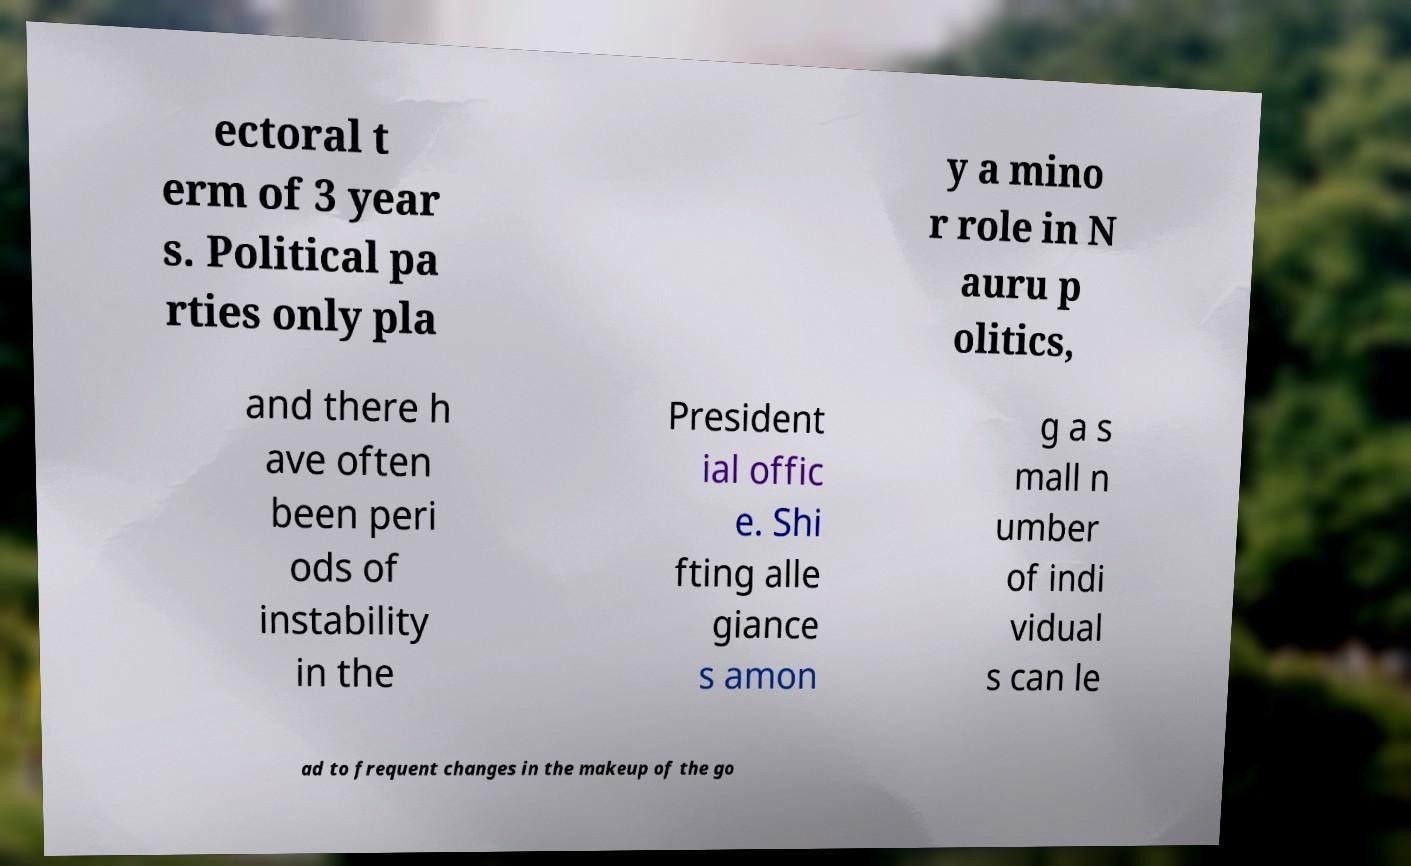Can you accurately transcribe the text from the provided image for me? ectoral t erm of 3 year s. Political pa rties only pla y a mino r role in N auru p olitics, and there h ave often been peri ods of instability in the President ial offic e. Shi fting alle giance s amon g a s mall n umber of indi vidual s can le ad to frequent changes in the makeup of the go 